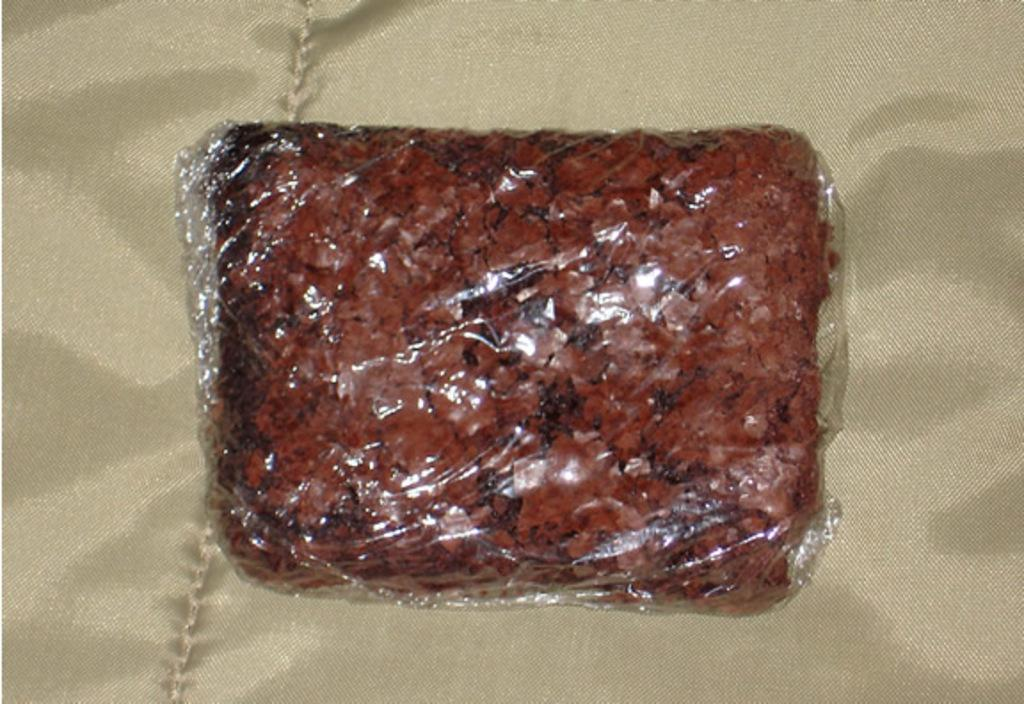What is the main subject of the image? There is a food item in the image. Does the food item have any specific features? Yes, the food item has a cover. What else can be seen in the image besides the food item? There is a cloth in the image. What type of pollution can be seen coming from the church in the image? There is no church or pollution present in the image. What kind of joke is being told by the cloth in the image? There is no joke being told by the cloth in the image; it is simply a cloth. 